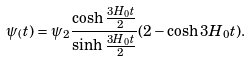Convert formula to latex. <formula><loc_0><loc_0><loc_500><loc_500>\psi _ { ( } t ) = \psi _ { 2 } \frac { \cosh \frac { 3 H _ { 0 } t } { 2 } } { \sinh \frac { 3 H _ { 0 } t } { 2 } } ( 2 - \cosh 3 H _ { 0 } t ) .</formula> 